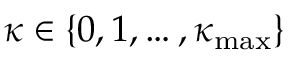<formula> <loc_0><loc_0><loc_500><loc_500>\kappa \in \{ 0 , 1 , \dots , \kappa _ { \max } \}</formula> 